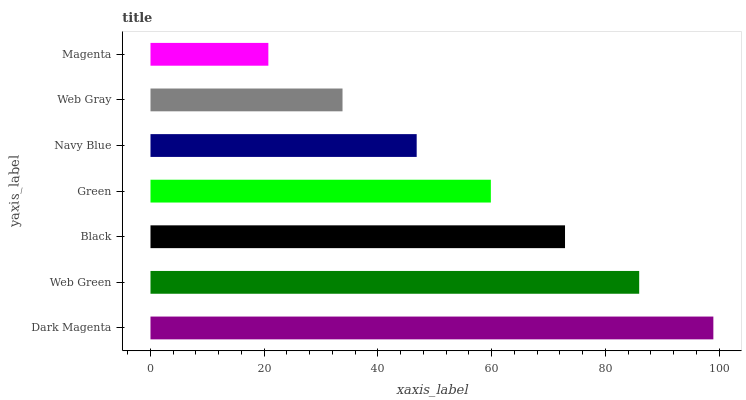Is Magenta the minimum?
Answer yes or no. Yes. Is Dark Magenta the maximum?
Answer yes or no. Yes. Is Web Green the minimum?
Answer yes or no. No. Is Web Green the maximum?
Answer yes or no. No. Is Dark Magenta greater than Web Green?
Answer yes or no. Yes. Is Web Green less than Dark Magenta?
Answer yes or no. Yes. Is Web Green greater than Dark Magenta?
Answer yes or no. No. Is Dark Magenta less than Web Green?
Answer yes or no. No. Is Green the high median?
Answer yes or no. Yes. Is Green the low median?
Answer yes or no. Yes. Is Black the high median?
Answer yes or no. No. Is Dark Magenta the low median?
Answer yes or no. No. 